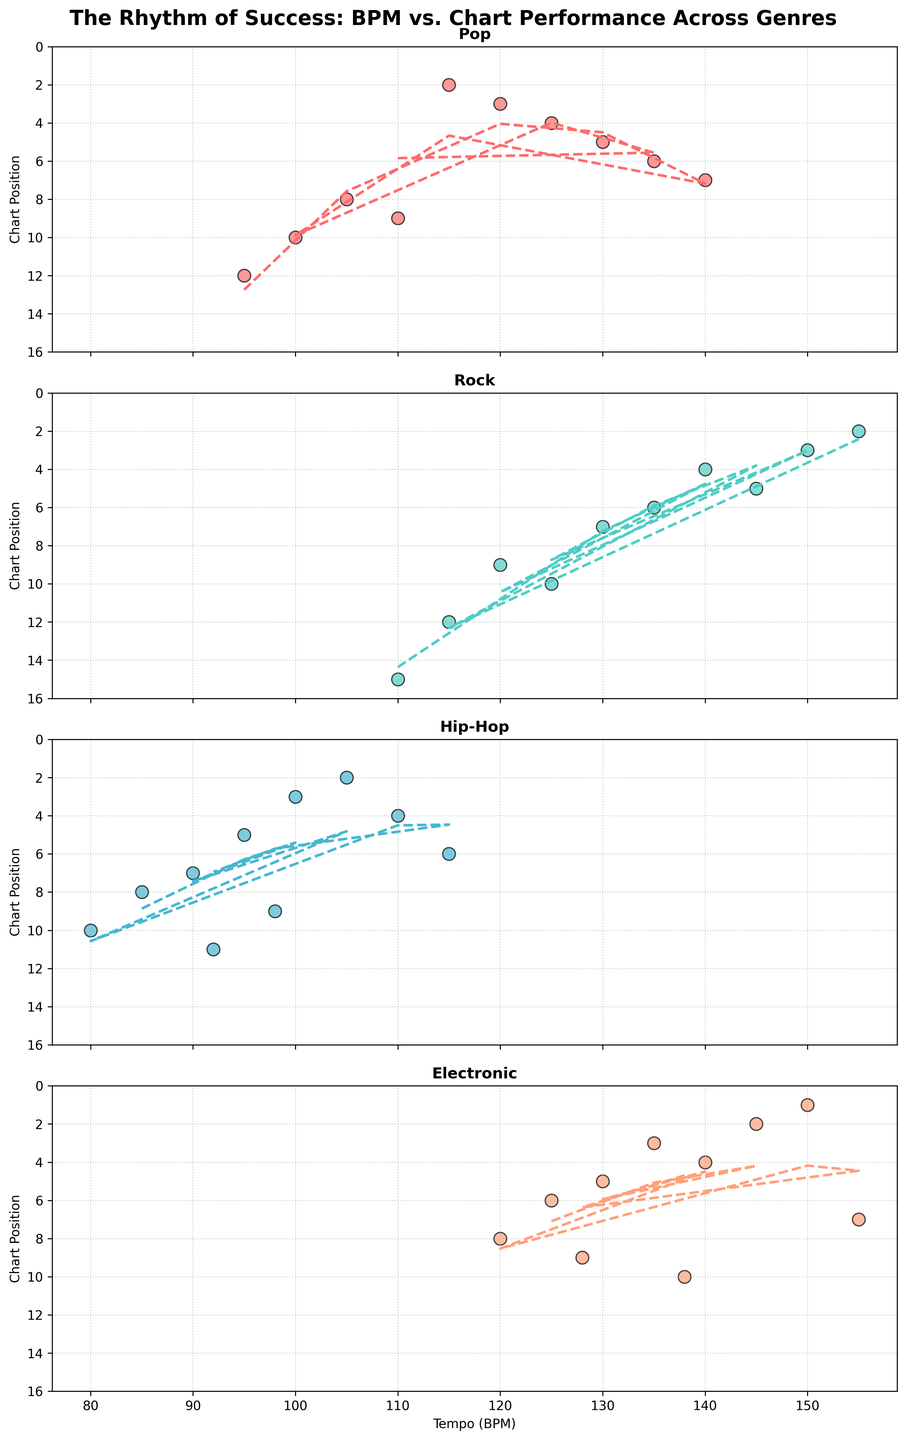What is the overall trend for Chart Position with increasing BPM in Pop music? By looking at the Pop subplot, it can be seen that as the BPM increases, there tends to be a downward trend in Chart Position, indicated by the polynomial regression line. This implies that songs with higher BPM tend to perform better on the charts in Pop music.
Answer: Higher BPM tends to correlate with better chart performance in Pop music Is there a particular BPM range where Rock songs perform better on the charts? Observing the Rock subplot, Rock songs that are within the BPM range of approximately 130 to 150 tend to have better chart positions. This is evident as many points in this range have lower Chart Positions, and the polynomial regression line dips within this range.
Answer: 130 to 150 BPM How does the BPM of top-performing Electronic songs compare to that of top-performing Hip-Hop songs? In the Electronic subplot, songs with BPMs between 125 to 155 tend to have better chart positions, particularly those around 150. In the Hip-Hop subplot, the top-performing songs have BPMs around 100 to 110. This indicates that higher BPMs are associated with top-performing Electronic songs compared to Hip-Hop songs.
Answer: Higher BPMs for Electronic, around 150 vs. 100-110 for Hip-Hop Which genre has the widest BPM range for charting songs? By examining the spread of BPM values in each subplot, Rock and Electronic music genres show the widest BPM range, stretching from approximately 110 to 155. In contrast, Pop and Hip-Hop have narrower ranges around 90 to 140 and 80 to 115, respectively.
Answer: Rock and Electronic What is the most frequent Chart Position range for Pop songs with BPMs greater than 120? Looking at the Pop subplot and focusing on BPMs greater than 120, the majority of Chart Positions appear to fall between 2 and 7. This indicates that Pop songs with higher BPMs generally perform well on the charts.
Answer: 2 to 7 